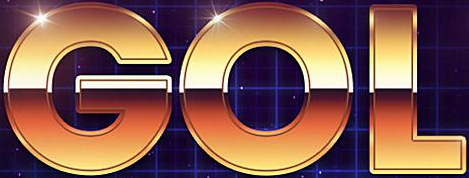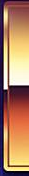What text is displayed in these images sequentially, separated by a semicolon? GOL; # 